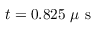Convert formula to latex. <formula><loc_0><loc_0><loc_500><loc_500>t = 0 . 8 2 5 \mu s</formula> 